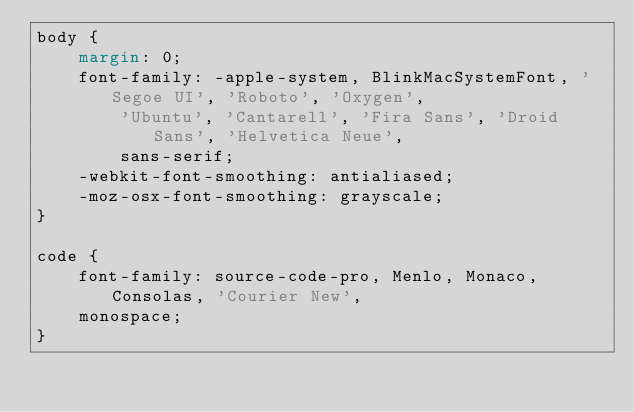<code> <loc_0><loc_0><loc_500><loc_500><_CSS_>body {
    margin: 0;
    font-family: -apple-system, BlinkMacSystemFont, 'Segoe UI', 'Roboto', 'Oxygen',
        'Ubuntu', 'Cantarell', 'Fira Sans', 'Droid Sans', 'Helvetica Neue',
        sans-serif;
    -webkit-font-smoothing: antialiased;
    -moz-osx-font-smoothing: grayscale;
}

code {
    font-family: source-code-pro, Menlo, Monaco, Consolas, 'Courier New',
    monospace;
}
</code> 